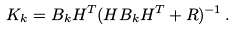Convert formula to latex. <formula><loc_0><loc_0><loc_500><loc_500>K _ { k } = B _ { k } H ^ { T } ( H B _ { k } H ^ { T } + R ) ^ { - 1 } \, .</formula> 